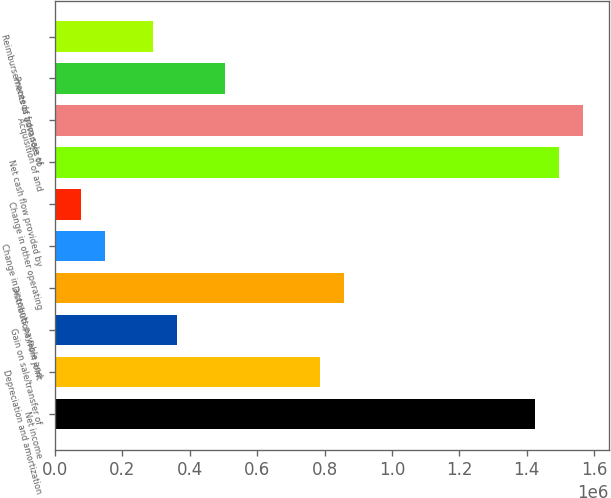Convert chart. <chart><loc_0><loc_0><loc_500><loc_500><bar_chart><fcel>Net income<fcel>Depreciation and amortization<fcel>Gain on sale/transfer of<fcel>Distributions from joint<fcel>Change in accounts payable and<fcel>Change in other operating<fcel>Net cash flow provided by<fcel>Acquisition of and<fcel>Proceeds from sale of<fcel>Reimbursements of advances to<nl><fcel>1.42373e+06<fcel>786787<fcel>362156<fcel>857559<fcel>149840<fcel>79067.9<fcel>1.49451e+06<fcel>1.56528e+06<fcel>503699<fcel>291384<nl></chart> 